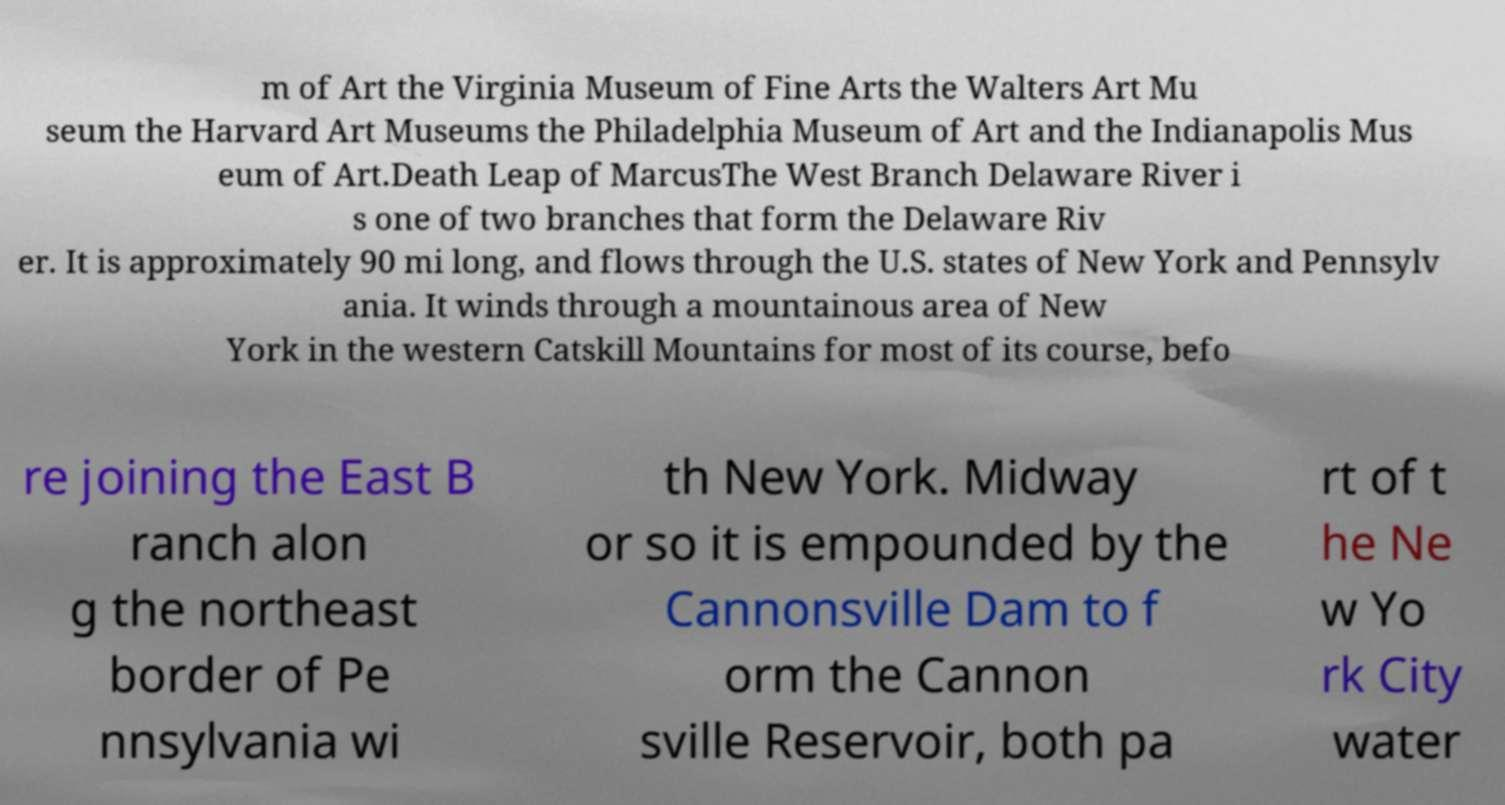Can you accurately transcribe the text from the provided image for me? m of Art the Virginia Museum of Fine Arts the Walters Art Mu seum the Harvard Art Museums the Philadelphia Museum of Art and the Indianapolis Mus eum of Art.Death Leap of MarcusThe West Branch Delaware River i s one of two branches that form the Delaware Riv er. It is approximately 90 mi long, and flows through the U.S. states of New York and Pennsylv ania. It winds through a mountainous area of New York in the western Catskill Mountains for most of its course, befo re joining the East B ranch alon g the northeast border of Pe nnsylvania wi th New York. Midway or so it is empounded by the Cannonsville Dam to f orm the Cannon sville Reservoir, both pa rt of t he Ne w Yo rk City water 